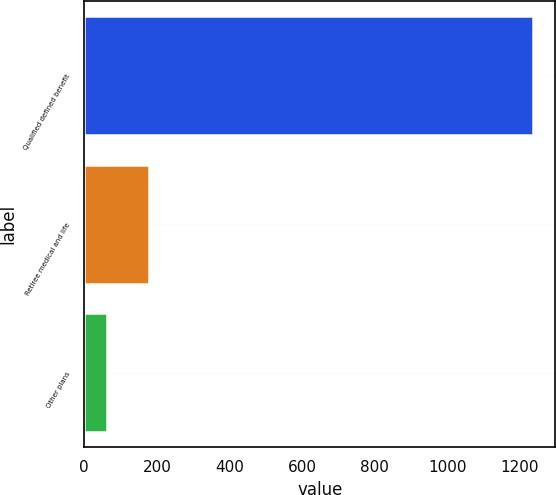Convert chart to OTSL. <chart><loc_0><loc_0><loc_500><loc_500><bar_chart><fcel>Qualified defined benefit<fcel>Retiree medical and life<fcel>Other plans<nl><fcel>1236<fcel>179.4<fcel>62<nl></chart> 